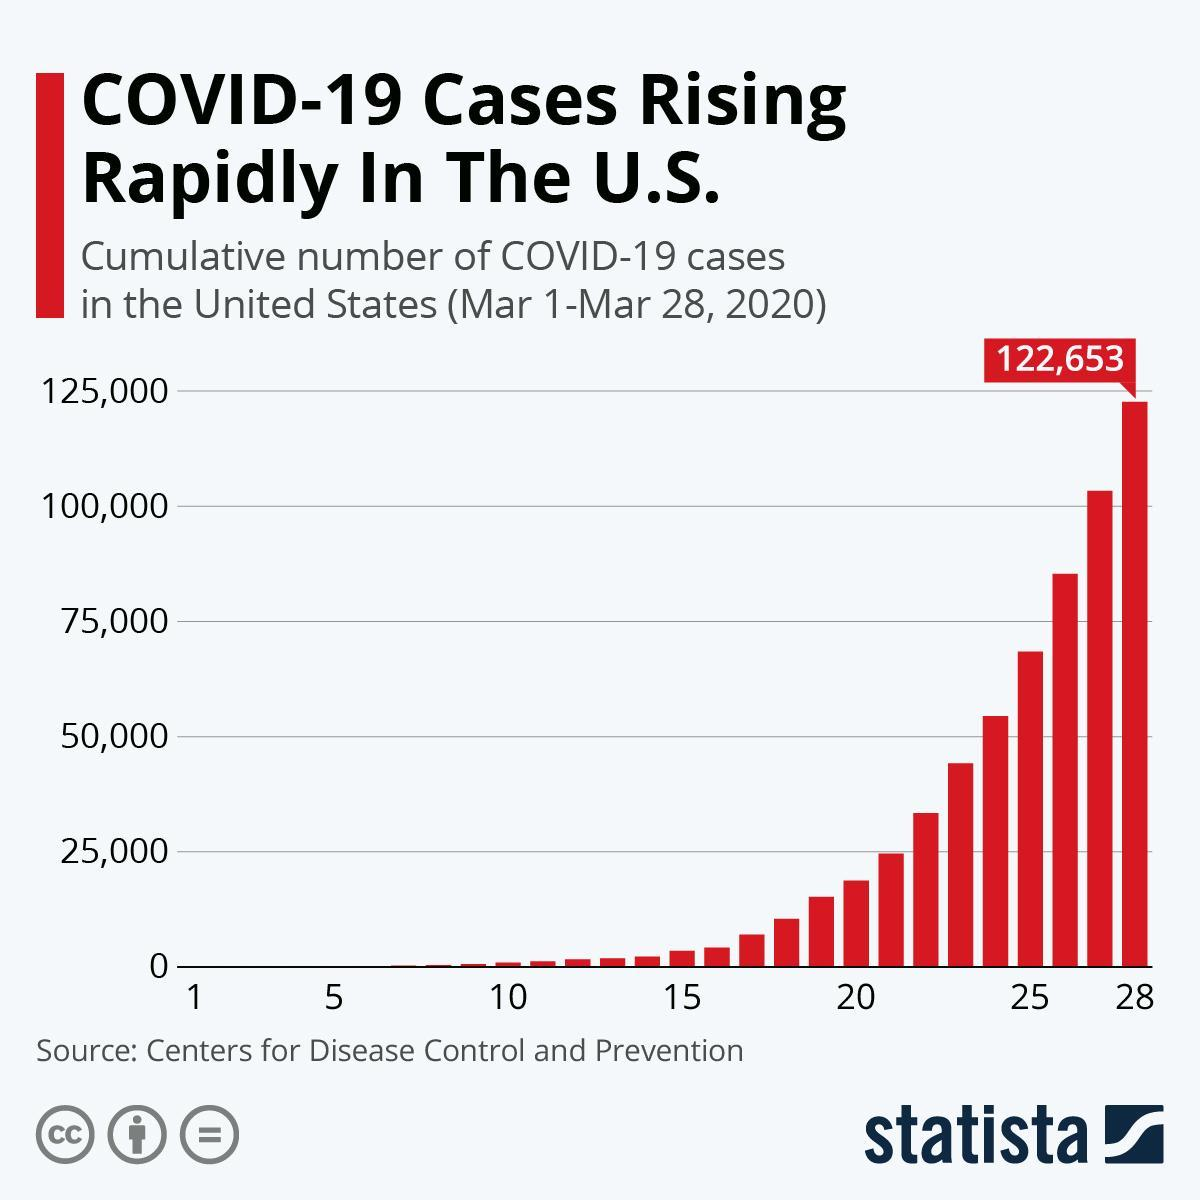After which date did COVID-19 cases cross 25000
Answer the question with a short phrase. 22 how many days did it take for COVID-19 cases to reach 25000 21 After which date did COVID-19 cases cross 75,000 25 what has been the total cases till March 28 122,653 